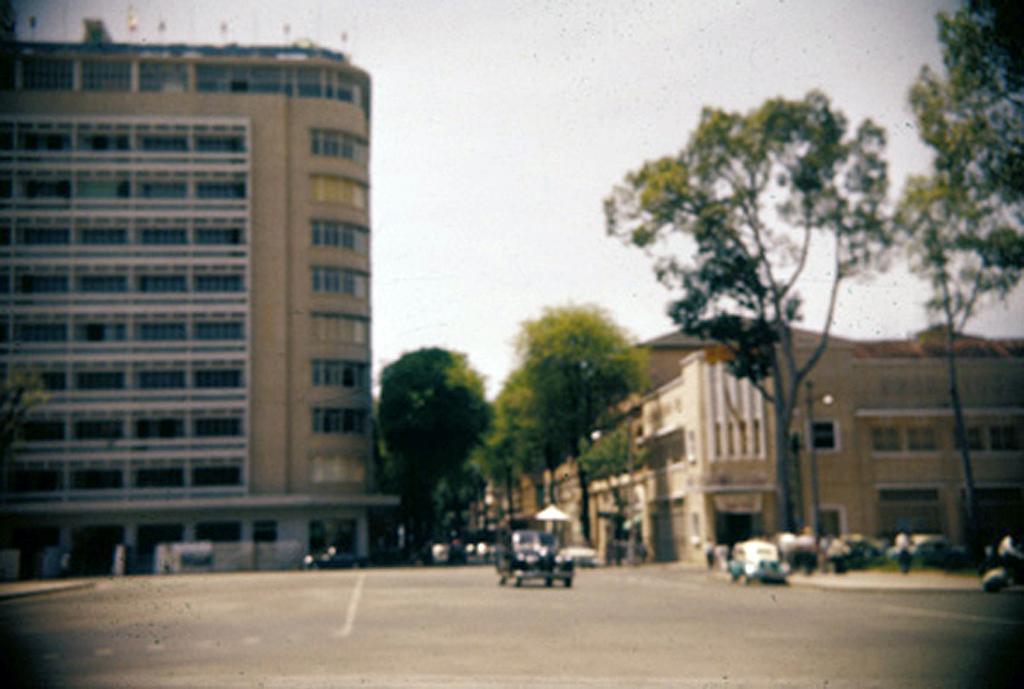How would you summarize this image in a sentence or two? In this picture we can see few vehicles and group of people, in the background we can see few buildings, trees and poles. 